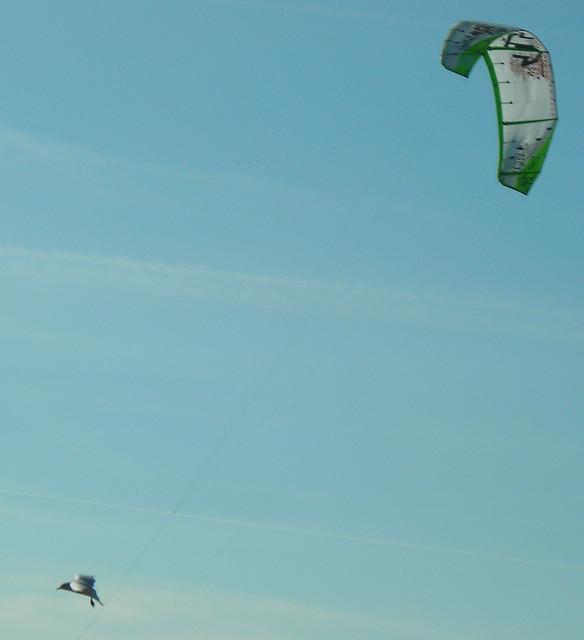How does the parachute stay in the air?
Concise answer only. Wind. Is it a bird in the sky?
Write a very short answer. Yes. Can you see the moon here?
Write a very short answer. No. What is in the sky?
Keep it brief. Parasail. 